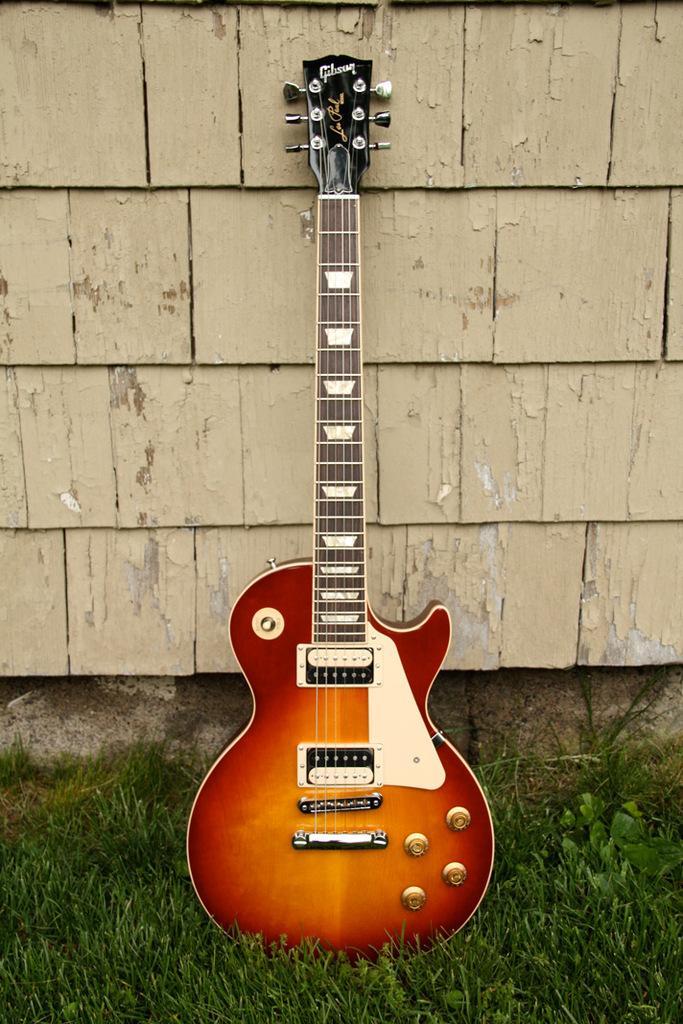How would you summarize this image in a sentence or two? In this image I can see a guitar, a wall and grass. 